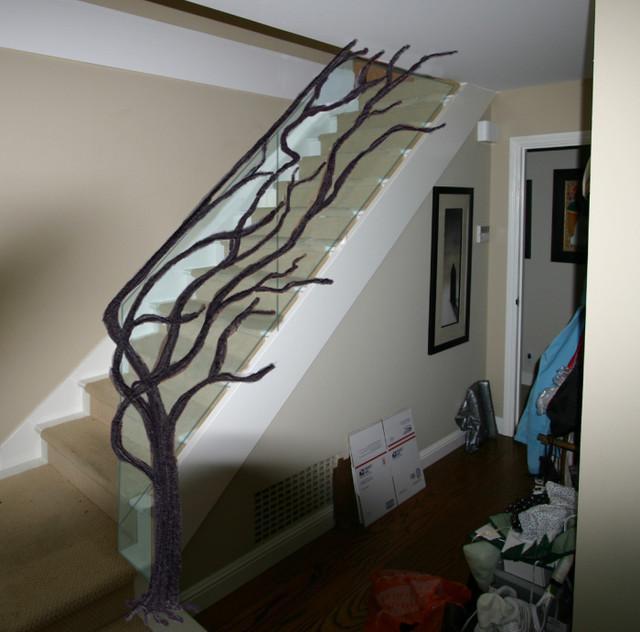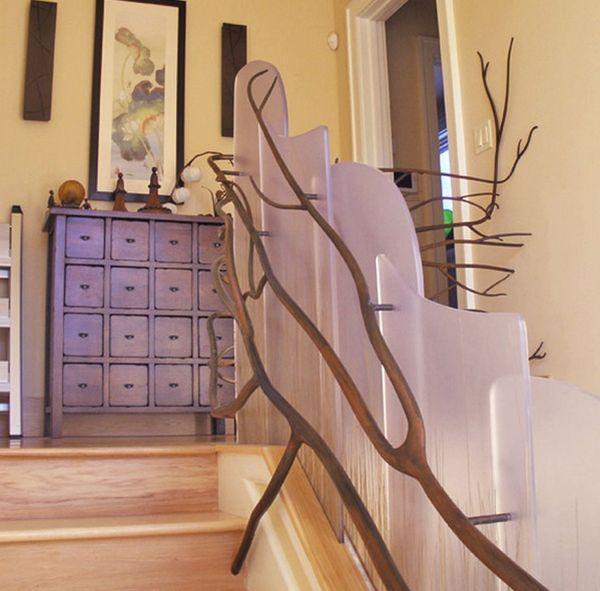The first image is the image on the left, the second image is the image on the right. Examine the images to the left and right. Is the description "In the left image, a tree shape with a trunk at the base of the staircase has branches forming the railing as the stairs ascend rightward." accurate? Answer yes or no. Yes. 